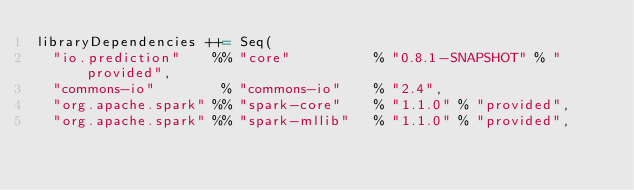<code> <loc_0><loc_0><loc_500><loc_500><_Scala_>libraryDependencies ++= Seq(
  "io.prediction"    %% "core"          % "0.8.1-SNAPSHOT" % "provided",
  "commons-io"        % "commons-io"    % "2.4",
  "org.apache.spark" %% "spark-core"    % "1.1.0" % "provided",
  "org.apache.spark" %% "spark-mllib"   % "1.1.0" % "provided",</code> 